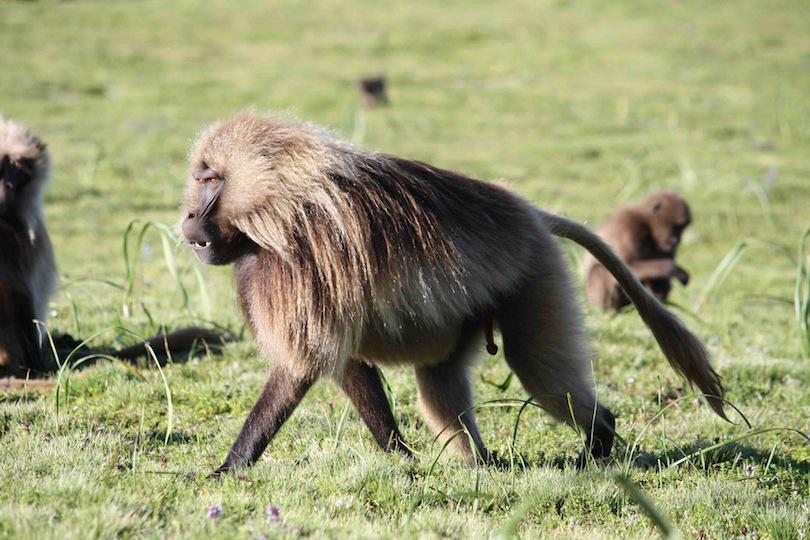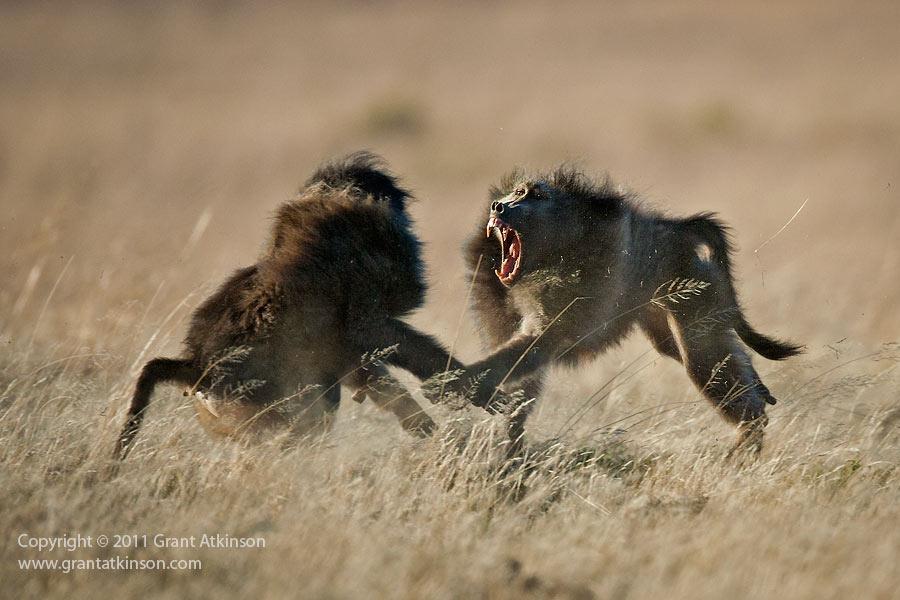The first image is the image on the left, the second image is the image on the right. Examine the images to the left and right. Is the description "In one image, two baboons are fighting, at least one with fangs bared, and the tail of the monkey on the left is extended with a bend in it." accurate? Answer yes or no. Yes. The first image is the image on the left, the second image is the image on the right. Evaluate the accuracy of this statement regarding the images: "A baboon is carrying its young in one of the images.". Is it true? Answer yes or no. No. 